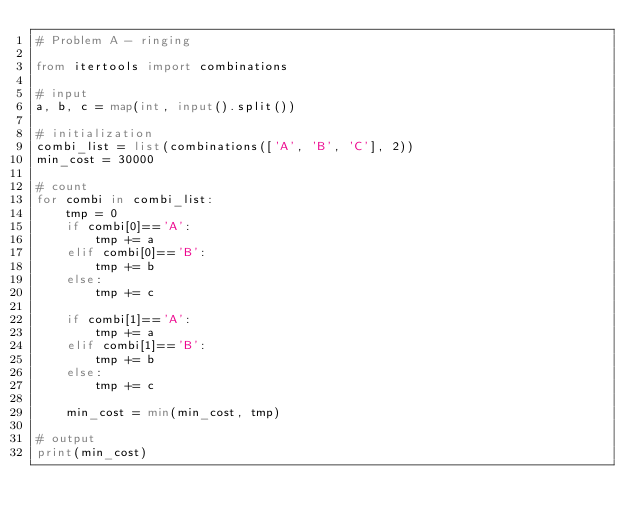Convert code to text. <code><loc_0><loc_0><loc_500><loc_500><_Python_># Problem A - ringing

from itertools import combinations

# input
a, b, c = map(int, input().split())

# initialization
combi_list = list(combinations(['A', 'B', 'C'], 2))
min_cost = 30000

# count
for combi in combi_list:
    tmp = 0
    if combi[0]=='A':
        tmp += a
    elif combi[0]=='B':
        tmp += b
    else:
        tmp += c

    if combi[1]=='A':
        tmp += a
    elif combi[1]=='B':
        tmp += b
    else:
        tmp += c

    min_cost = min(min_cost, tmp)

# output
print(min_cost)
</code> 